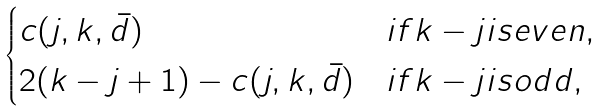<formula> <loc_0><loc_0><loc_500><loc_500>\begin{cases} c ( j , k , \bar { d } ) & i f k - j i s e v e n , \\ 2 ( k - j + 1 ) - c ( j , k , \bar { d } ) & i f k - j i s o d d , \end{cases}</formula> 